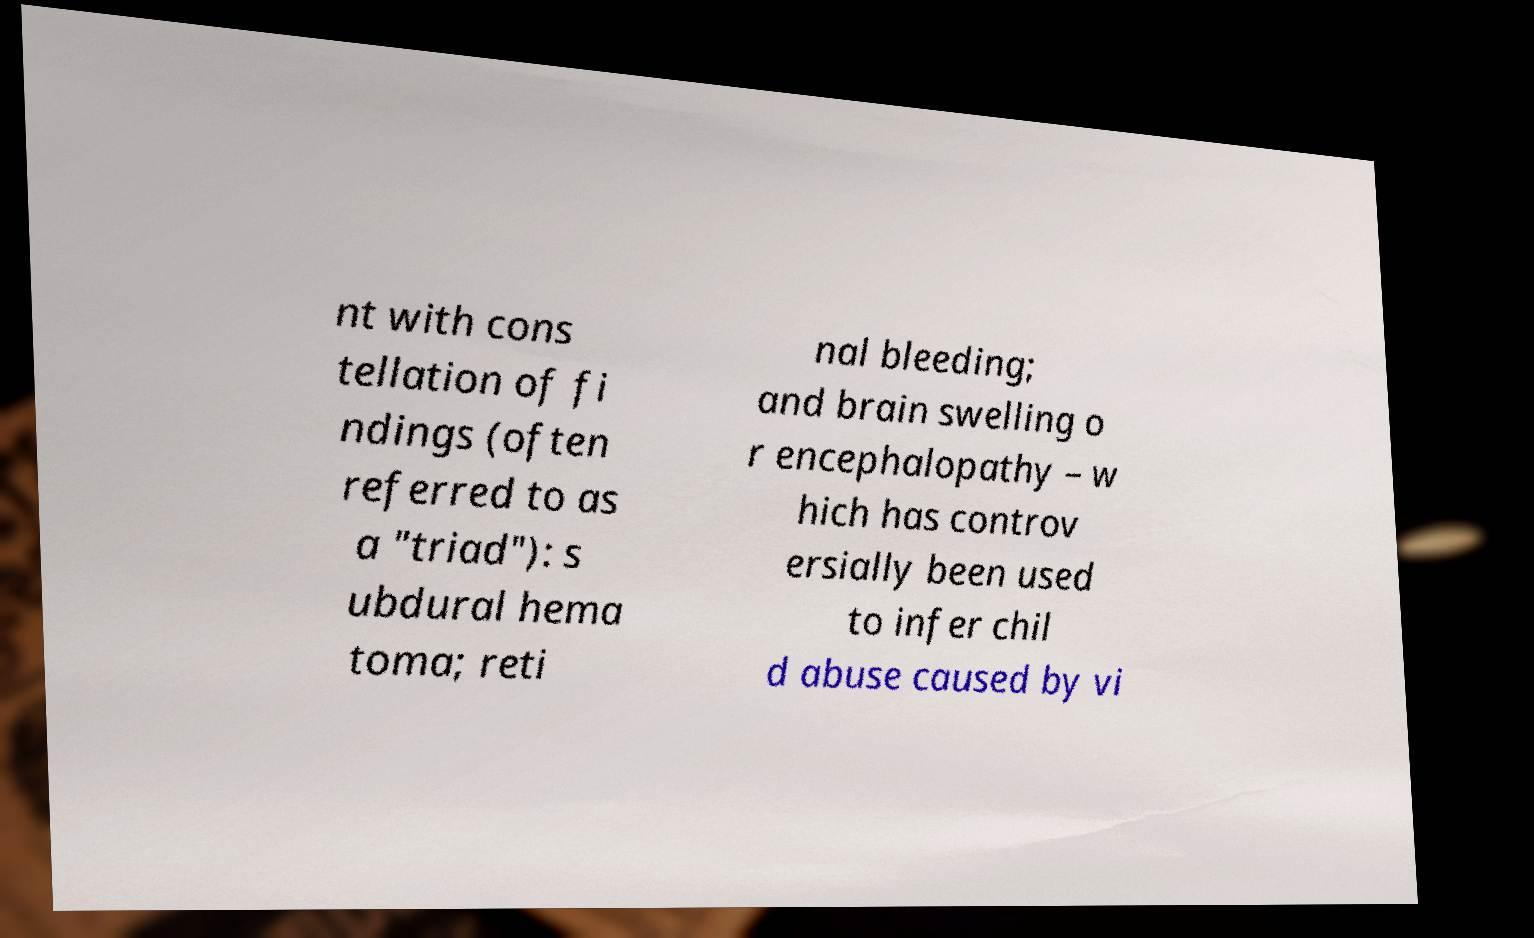For documentation purposes, I need the text within this image transcribed. Could you provide that? nt with cons tellation of fi ndings (often referred to as a "triad"): s ubdural hema toma; reti nal bleeding; and brain swelling o r encephalopathy – w hich has controv ersially been used to infer chil d abuse caused by vi 